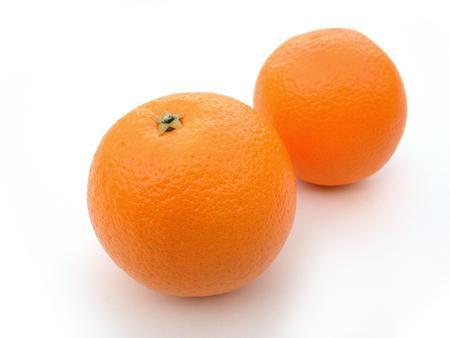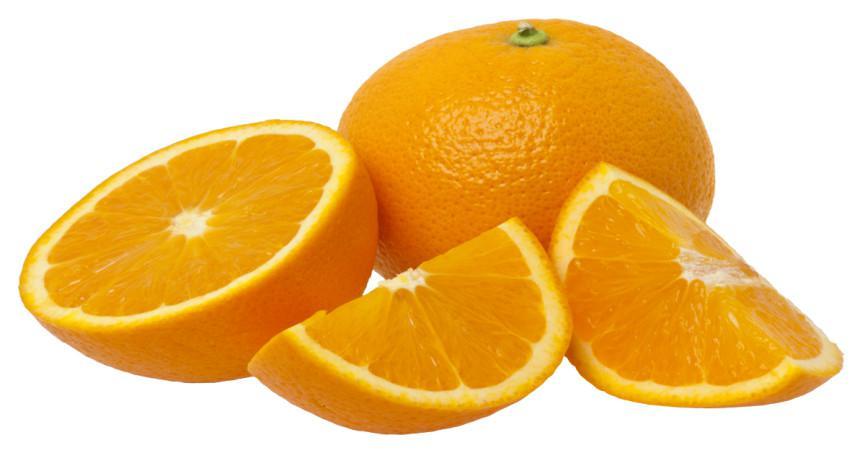The first image is the image on the left, the second image is the image on the right. For the images shown, is this caption "One of the images has exactly two uncut oranges without any other fruits present." true? Answer yes or no. Yes. 